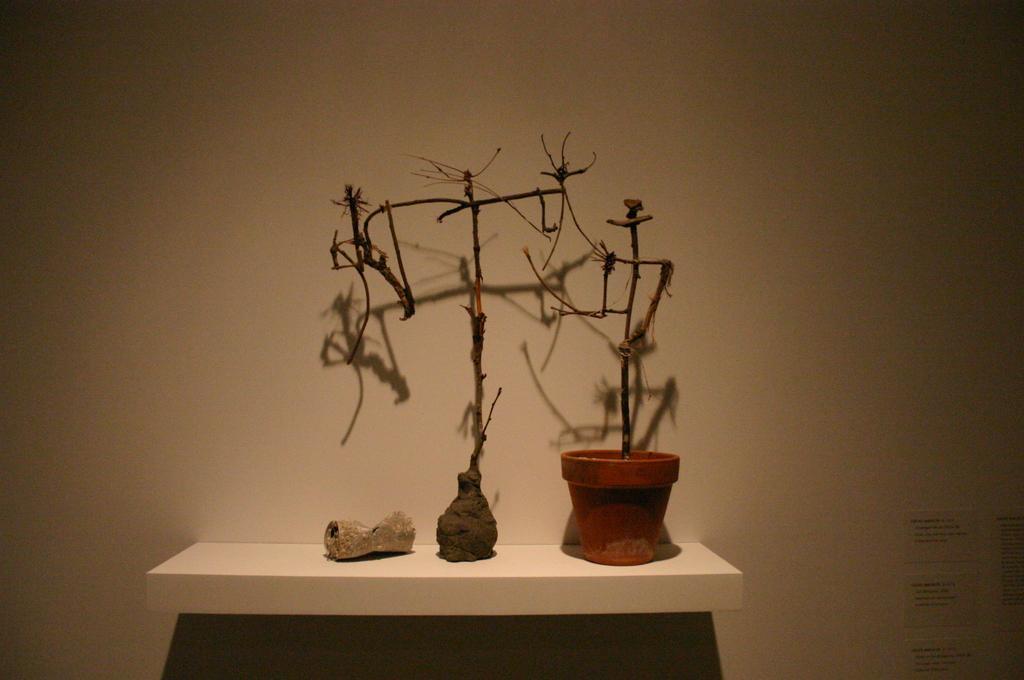Describe this image in one or two sentences. In front of a wall there is a shelf and on the shelf there is dry plant and two other objects. The shadow of the plant is being reflected on the wall. 